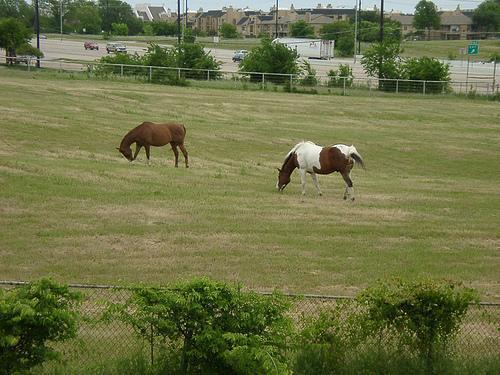How many animals are there?
Give a very brief answer. 2. How many semi-trucks are there?
Give a very brief answer. 1. 